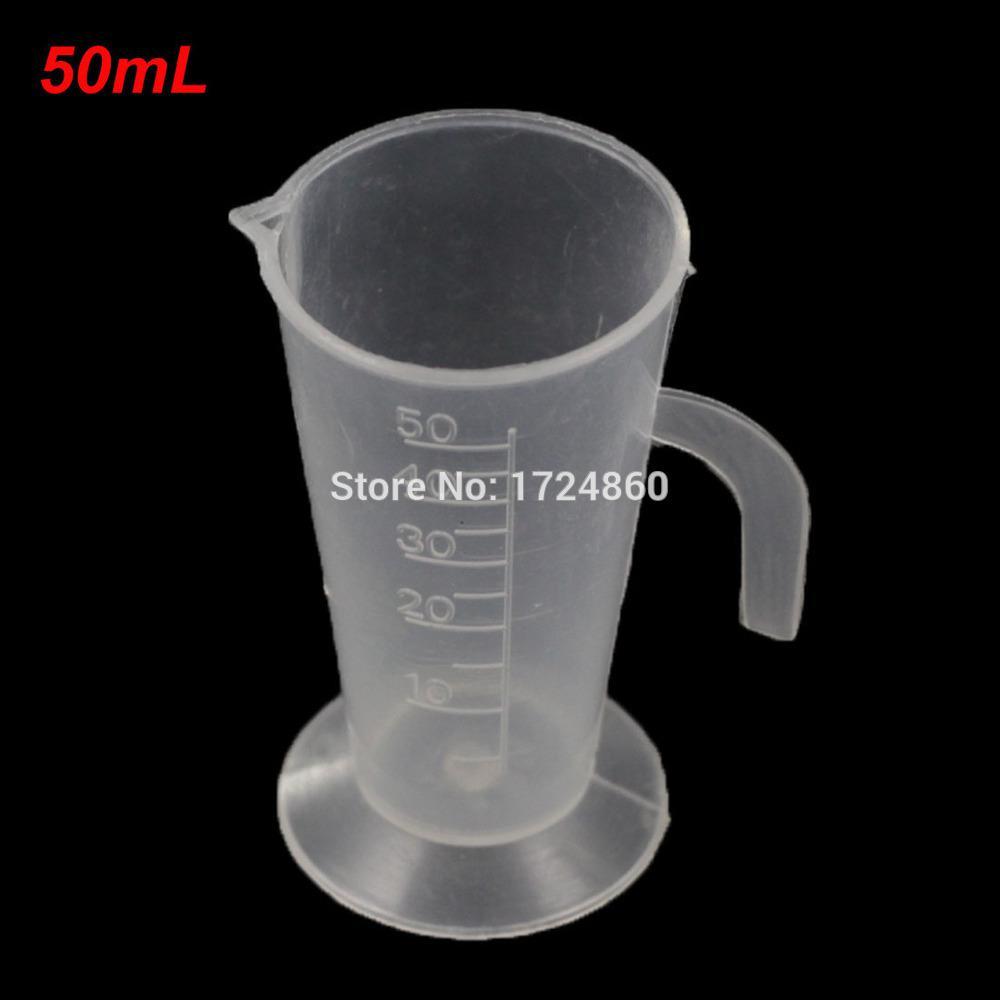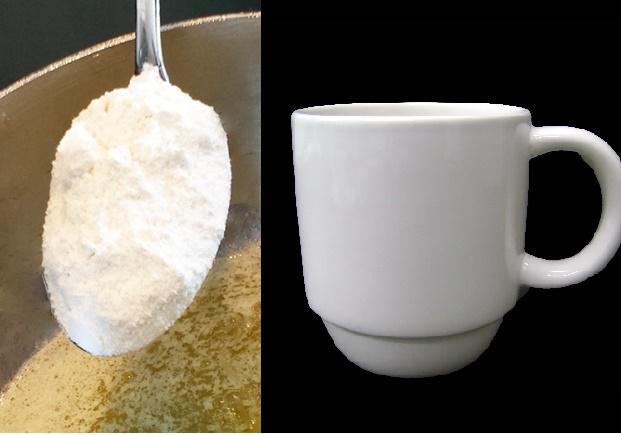The first image is the image on the left, the second image is the image on the right. Analyze the images presented: Is the assertion "In total, there are two cups and one spoon." valid? Answer yes or no. Yes. 